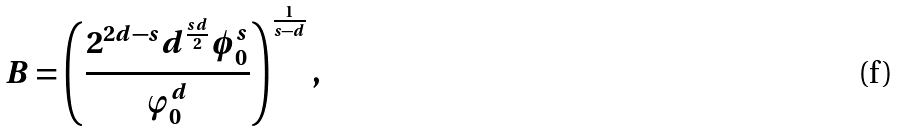<formula> <loc_0><loc_0><loc_500><loc_500>B = \left ( \frac { 2 ^ { 2 d - s } d ^ { \frac { s d } { 2 } } \phi _ { 0 } ^ { s } } { \varphi _ { 0 } ^ { d } } \right ) ^ { \frac { 1 } { s - d } } ,</formula> 